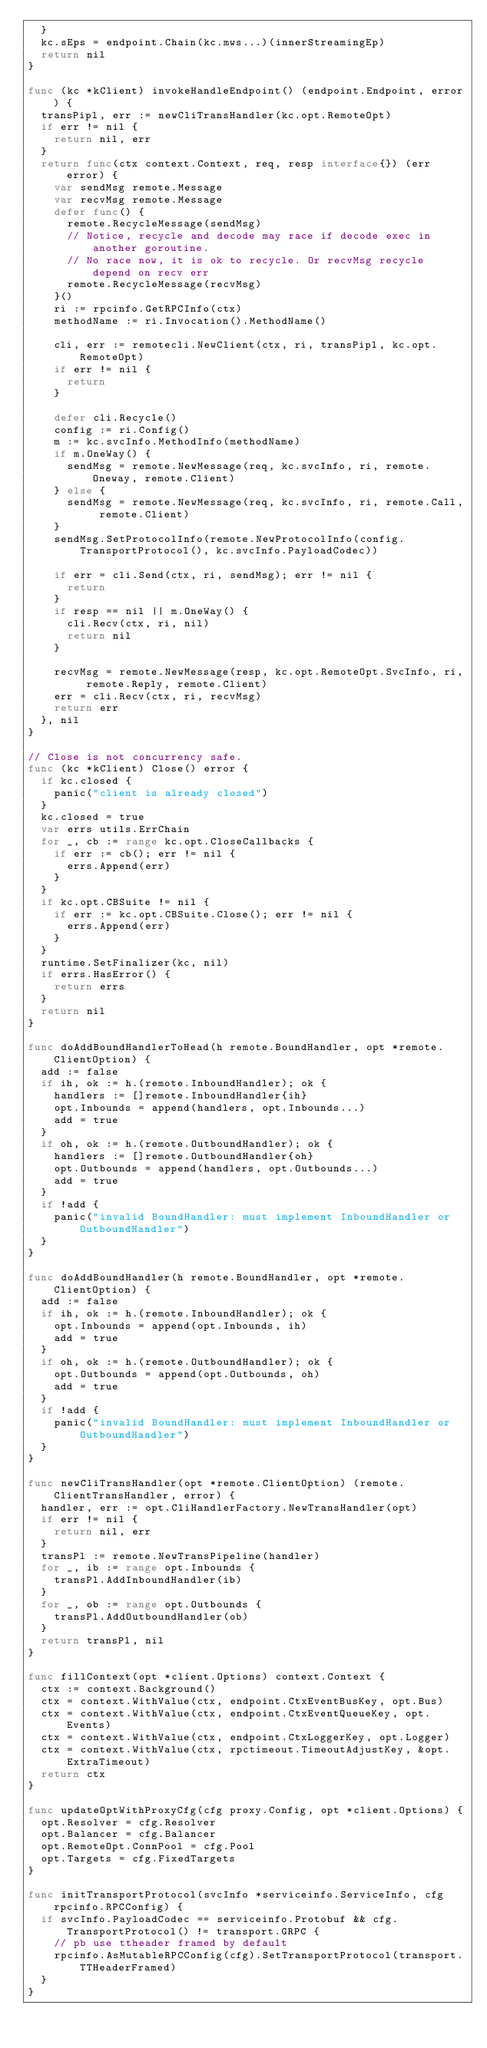<code> <loc_0><loc_0><loc_500><loc_500><_Go_>	}
	kc.sEps = endpoint.Chain(kc.mws...)(innerStreamingEp)
	return nil
}

func (kc *kClient) invokeHandleEndpoint() (endpoint.Endpoint, error) {
	transPipl, err := newCliTransHandler(kc.opt.RemoteOpt)
	if err != nil {
		return nil, err
	}
	return func(ctx context.Context, req, resp interface{}) (err error) {
		var sendMsg remote.Message
		var recvMsg remote.Message
		defer func() {
			remote.RecycleMessage(sendMsg)
			// Notice, recycle and decode may race if decode exec in another goroutine.
			// No race now, it is ok to recycle. Or recvMsg recycle depend on recv err
			remote.RecycleMessage(recvMsg)
		}()
		ri := rpcinfo.GetRPCInfo(ctx)
		methodName := ri.Invocation().MethodName()

		cli, err := remotecli.NewClient(ctx, ri, transPipl, kc.opt.RemoteOpt)
		if err != nil {
			return
		}

		defer cli.Recycle()
		config := ri.Config()
		m := kc.svcInfo.MethodInfo(methodName)
		if m.OneWay() {
			sendMsg = remote.NewMessage(req, kc.svcInfo, ri, remote.Oneway, remote.Client)
		} else {
			sendMsg = remote.NewMessage(req, kc.svcInfo, ri, remote.Call, remote.Client)
		}
		sendMsg.SetProtocolInfo(remote.NewProtocolInfo(config.TransportProtocol(), kc.svcInfo.PayloadCodec))

		if err = cli.Send(ctx, ri, sendMsg); err != nil {
			return
		}
		if resp == nil || m.OneWay() {
			cli.Recv(ctx, ri, nil)
			return nil
		}

		recvMsg = remote.NewMessage(resp, kc.opt.RemoteOpt.SvcInfo, ri, remote.Reply, remote.Client)
		err = cli.Recv(ctx, ri, recvMsg)
		return err
	}, nil
}

// Close is not concurrency safe.
func (kc *kClient) Close() error {
	if kc.closed {
		panic("client is already closed")
	}
	kc.closed = true
	var errs utils.ErrChain
	for _, cb := range kc.opt.CloseCallbacks {
		if err := cb(); err != nil {
			errs.Append(err)
		}
	}
	if kc.opt.CBSuite != nil {
		if err := kc.opt.CBSuite.Close(); err != nil {
			errs.Append(err)
		}
	}
	runtime.SetFinalizer(kc, nil)
	if errs.HasError() {
		return errs
	}
	return nil
}

func doAddBoundHandlerToHead(h remote.BoundHandler, opt *remote.ClientOption) {
	add := false
	if ih, ok := h.(remote.InboundHandler); ok {
		handlers := []remote.InboundHandler{ih}
		opt.Inbounds = append(handlers, opt.Inbounds...)
		add = true
	}
	if oh, ok := h.(remote.OutboundHandler); ok {
		handlers := []remote.OutboundHandler{oh}
		opt.Outbounds = append(handlers, opt.Outbounds...)
		add = true
	}
	if !add {
		panic("invalid BoundHandler: must implement InboundHandler or OutboundHandler")
	}
}

func doAddBoundHandler(h remote.BoundHandler, opt *remote.ClientOption) {
	add := false
	if ih, ok := h.(remote.InboundHandler); ok {
		opt.Inbounds = append(opt.Inbounds, ih)
		add = true
	}
	if oh, ok := h.(remote.OutboundHandler); ok {
		opt.Outbounds = append(opt.Outbounds, oh)
		add = true
	}
	if !add {
		panic("invalid BoundHandler: must implement InboundHandler or OutboundHandler")
	}
}

func newCliTransHandler(opt *remote.ClientOption) (remote.ClientTransHandler, error) {
	handler, err := opt.CliHandlerFactory.NewTransHandler(opt)
	if err != nil {
		return nil, err
	}
	transPl := remote.NewTransPipeline(handler)
	for _, ib := range opt.Inbounds {
		transPl.AddInboundHandler(ib)
	}
	for _, ob := range opt.Outbounds {
		transPl.AddOutboundHandler(ob)
	}
	return transPl, nil
}

func fillContext(opt *client.Options) context.Context {
	ctx := context.Background()
	ctx = context.WithValue(ctx, endpoint.CtxEventBusKey, opt.Bus)
	ctx = context.WithValue(ctx, endpoint.CtxEventQueueKey, opt.Events)
	ctx = context.WithValue(ctx, endpoint.CtxLoggerKey, opt.Logger)
	ctx = context.WithValue(ctx, rpctimeout.TimeoutAdjustKey, &opt.ExtraTimeout)
	return ctx
}

func updateOptWithProxyCfg(cfg proxy.Config, opt *client.Options) {
	opt.Resolver = cfg.Resolver
	opt.Balancer = cfg.Balancer
	opt.RemoteOpt.ConnPool = cfg.Pool
	opt.Targets = cfg.FixedTargets
}

func initTransportProtocol(svcInfo *serviceinfo.ServiceInfo, cfg rpcinfo.RPCConfig) {
	if svcInfo.PayloadCodec == serviceinfo.Protobuf && cfg.TransportProtocol() != transport.GRPC {
		// pb use ttheader framed by default
		rpcinfo.AsMutableRPCConfig(cfg).SetTransportProtocol(transport.TTHeaderFramed)
	}
}
</code> 